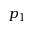Convert formula to latex. <formula><loc_0><loc_0><loc_500><loc_500>p _ { 1 }</formula> 